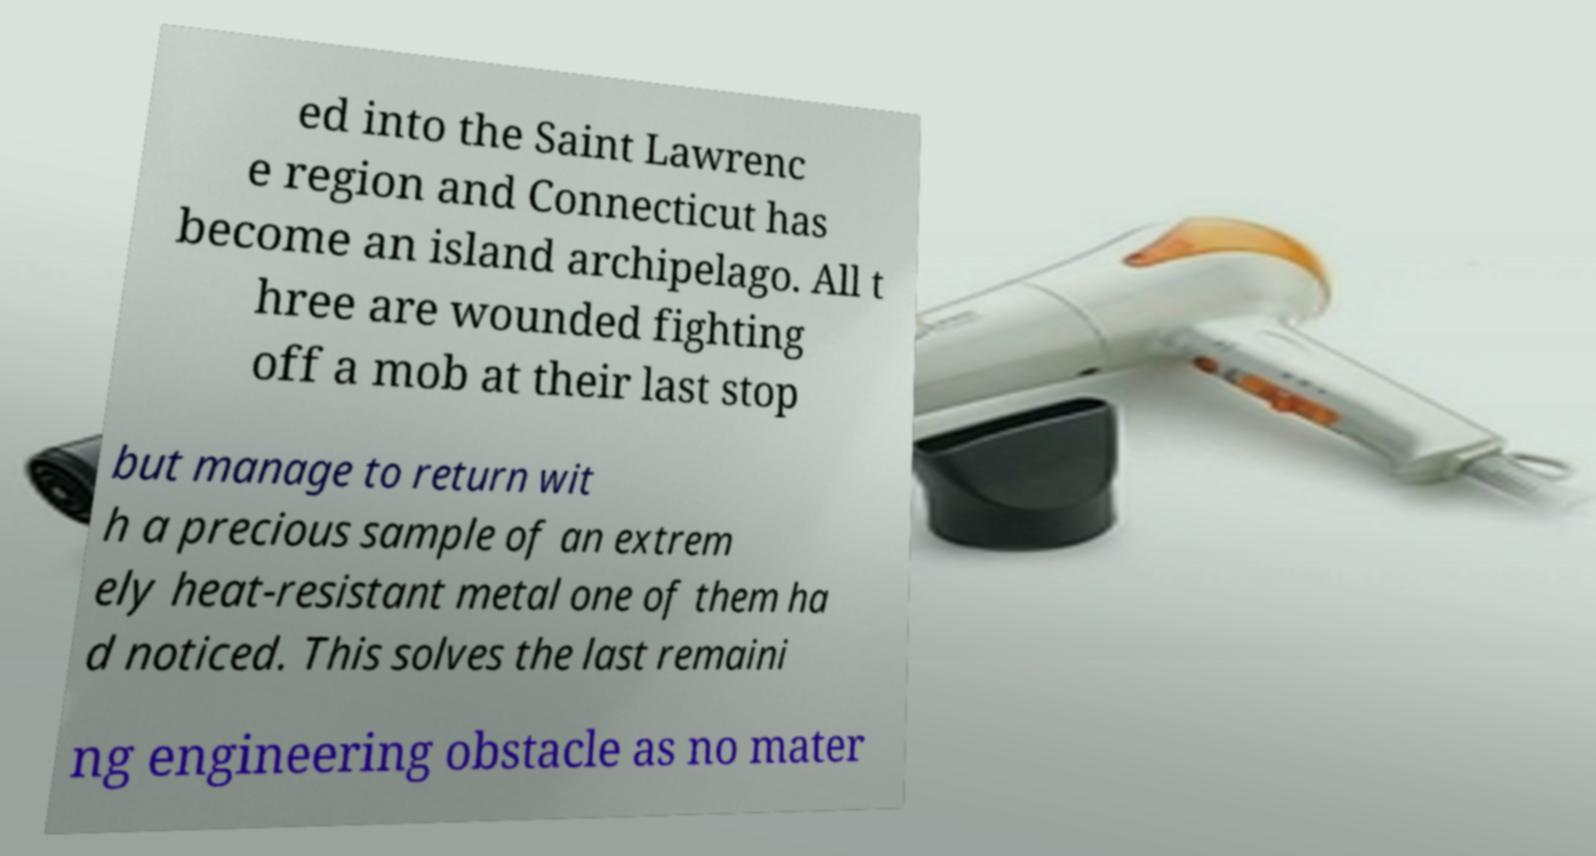Please identify and transcribe the text found in this image. ed into the Saint Lawrenc e region and Connecticut has become an island archipelago. All t hree are wounded fighting off a mob at their last stop but manage to return wit h a precious sample of an extrem ely heat-resistant metal one of them ha d noticed. This solves the last remaini ng engineering obstacle as no mater 